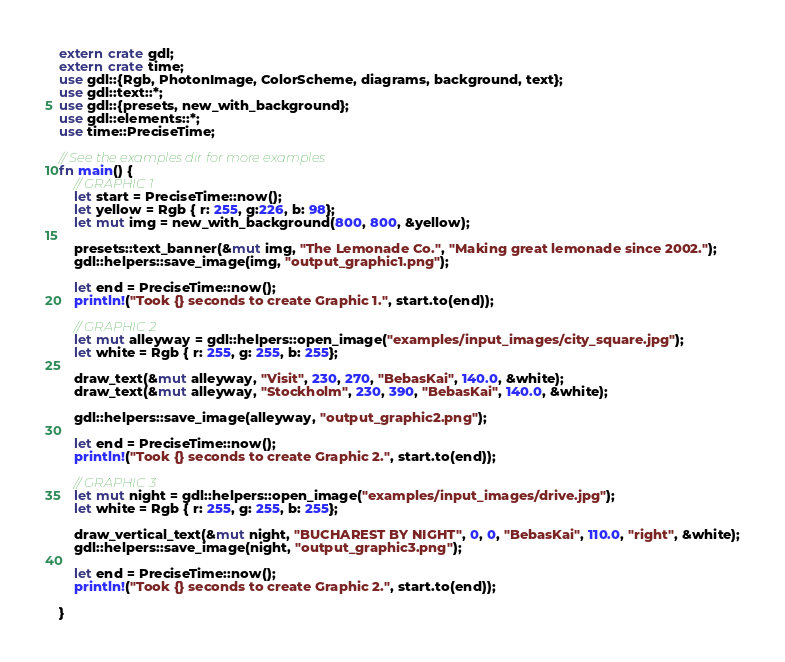Convert code to text. <code><loc_0><loc_0><loc_500><loc_500><_Rust_>extern crate gdl;
extern crate time;
use gdl::{Rgb, PhotonImage, ColorScheme, diagrams, background, text};
use gdl::text::*;
use gdl::{presets, new_with_background};
use gdl::elements::*;
use time::PreciseTime;

// See the examples dir for more examples
fn main() {
    // GRAPHIC 1
    let start = PreciseTime::now();
    let yellow = Rgb { r: 255, g:226, b: 98};
    let mut img = new_with_background(800, 800, &yellow);

    presets::text_banner(&mut img, "The Lemonade Co.", "Making great lemonade since 2002.");
    gdl::helpers::save_image(img, "output_graphic1.png");

    let end = PreciseTime::now();
    println!("Took {} seconds to create Graphic 1.", start.to(end));

    // GRAPHIC 2 
    let mut alleyway = gdl::helpers::open_image("examples/input_images/city_square.jpg");
    let white = Rgb { r: 255, g: 255, b: 255};

    draw_text(&mut alleyway, "Visit", 230, 270, "BebasKai", 140.0, &white);
    draw_text(&mut alleyway, "Stockholm", 230, 390, "BebasKai", 140.0, &white);

    gdl::helpers::save_image(alleyway, "output_graphic2.png");

    let end = PreciseTime::now();
    println!("Took {} seconds to create Graphic 2.", start.to(end));

    // GRAPHIC 3 
    let mut night = gdl::helpers::open_image("examples/input_images/drive.jpg");
    let white = Rgb { r: 255, g: 255, b: 255};

    draw_vertical_text(&mut night, "BUCHAREST BY NIGHT", 0, 0, "BebasKai", 110.0, "right", &white);
    gdl::helpers::save_image(night, "output_graphic3.png");

    let end = PreciseTime::now();
    println!("Took {} seconds to create Graphic 2.", start.to(end));

}</code> 